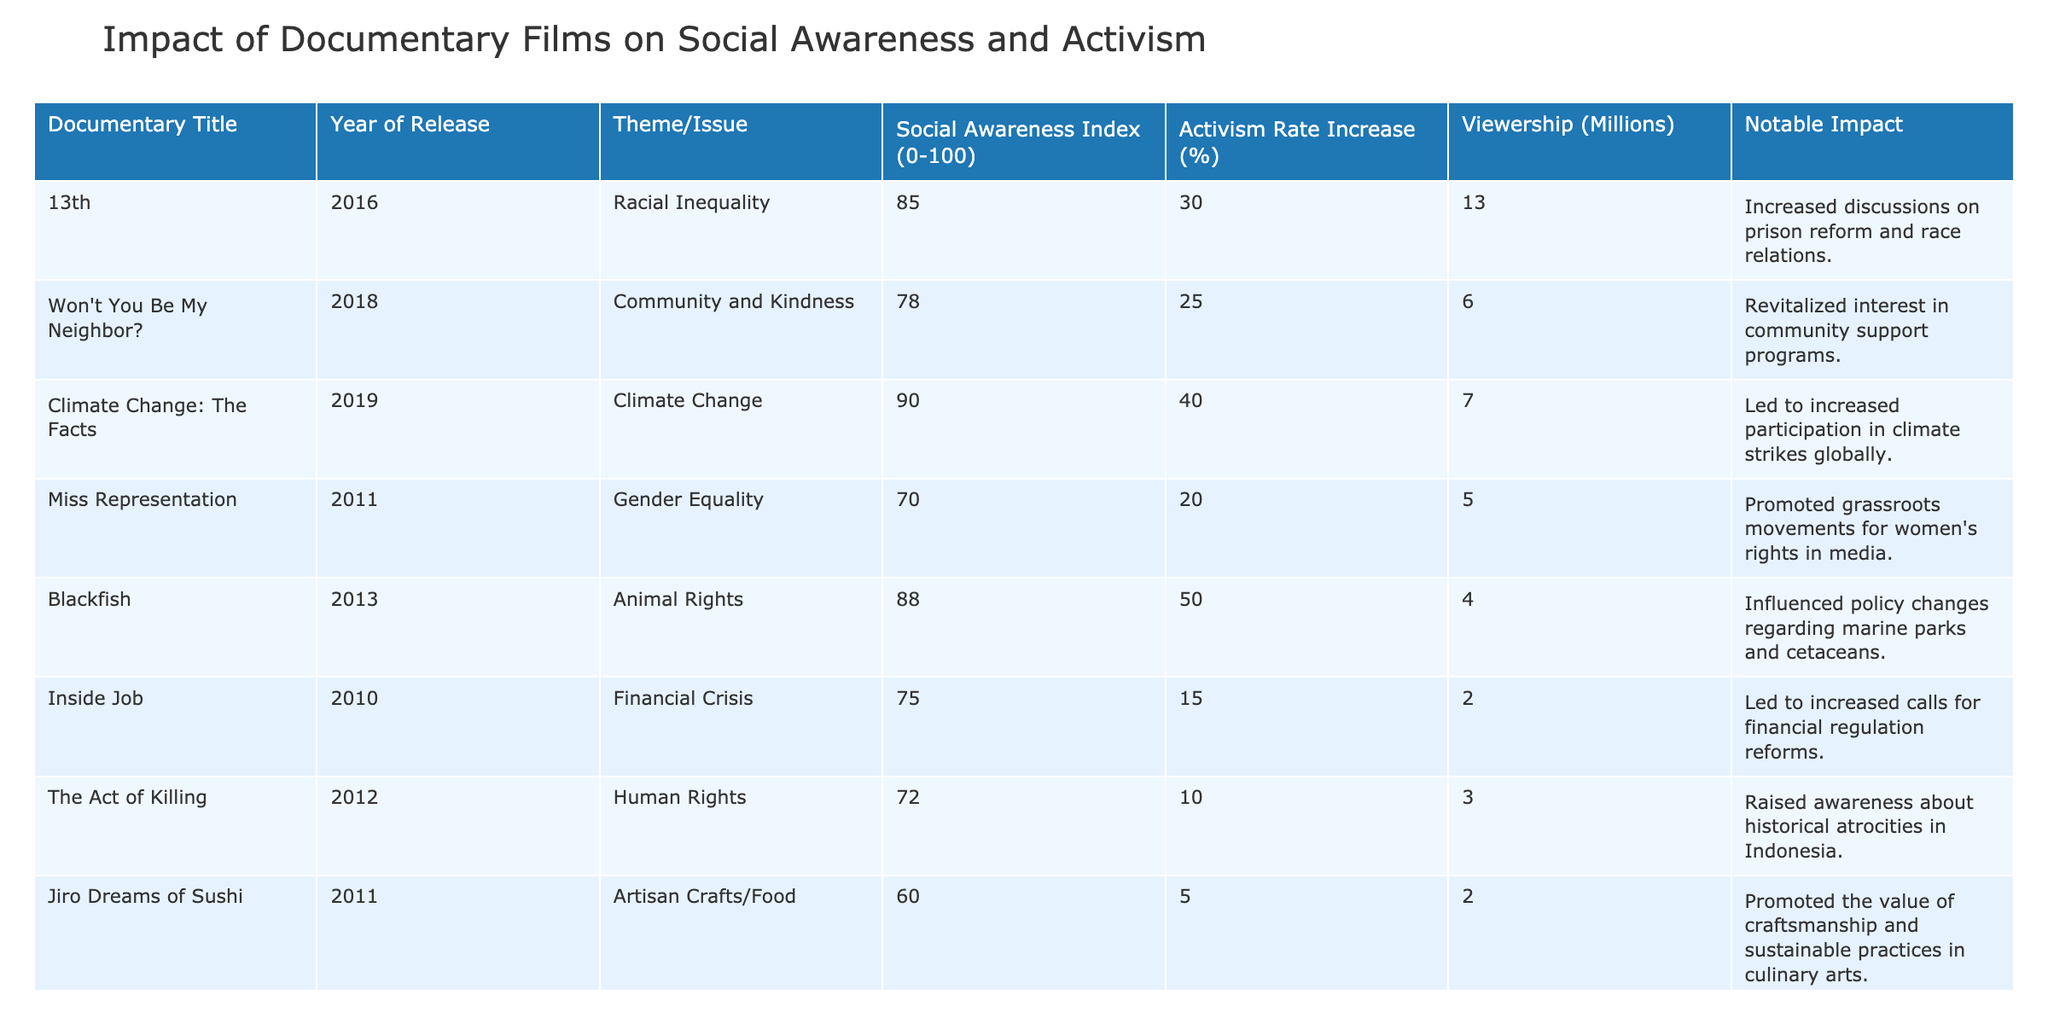What is the Social Awareness Index for "Blackfish"? Referring to the table, under the "Social Awareness Index" column, the value corresponding to "Blackfish" is clearly listed as 88.
Answer: 88 What was the Activism Rate Increase (%) for "13th"? The table shows that the Activism Rate Increase for "13th" is 30%, which can be found in the respective column next to the documentary title.
Answer: 30% Which documentary had the highest viewership? By comparing the "Viewership (Millions)" column, it is evident that "13th" had the highest viewership at 13 million.
Answer: 13 million What is the average Activism Rate Increase for all documentaries listed? To find the average, we sum the Activism Rate increases: 30 + 25 + 40 + 20 + 50 + 15 + 10 + 5 + 30 = 225. There are 9 documentaries, so the average is 225/9 = 25.
Answer: 25 Did "Inside Job" lead to an increase in activism? Looking at the Activism Rate Increase for "Inside Job," which is 15%, we can consider it as a low but positive rate. Therefore, it can be concluded that it did lead to some increase.
Answer: Yes How many documentaries focused on Community and Kindness or Animal Rights? By examining the "Theme/Issue" column, we note that there is 1 documentary explicitly labeled for Community and Kindness ("Won't You Be My Neighbor?") and 1 for Animal Rights ("Blackfish"). Thus, the total is 2.
Answer: 2 Is the Activism Rate Increase higher for "Climate Change: The Facts" than for "Miss Representation"? By directly comparing, "Climate Change: The Facts" has an increase of 40%, while "Miss Representation" has 20%. Since 40% is greater than 20%, the statement is true.
Answer: Yes What is the difference in Social Awareness Index between "Jiro Dreams of Sushi" and "The True Cost"? The Social Awareness Index for "Jiro Dreams of Sushi" is 60 and for "The True Cost" it is 80. The difference is 80 - 60 = 20.
Answer: 20 Which documentary had a notable impact related to climate strikes? The table indicates that "Climate Change: The Facts" is associated with increased participation in climate strikes globally, making it the documentary linked to this impact.
Answer: Climate Change: The Facts 